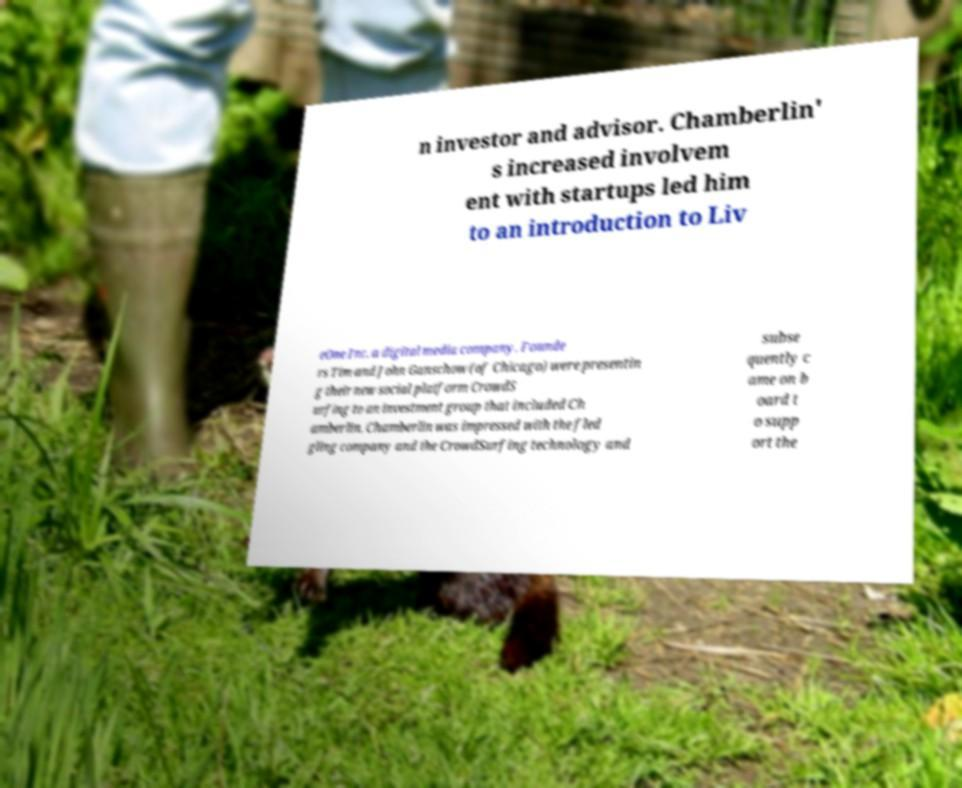For documentation purposes, I need the text within this image transcribed. Could you provide that? n investor and advisor. Chamberlin' s increased involvem ent with startups led him to an introduction to Liv eOne Inc. a digital media company. Founde rs Tim and John Ganschow (of Chicago) were presentin g their new social platform CrowdS urfing to an investment group that included Ch amberlin. Chamberlin was impressed with the fled gling company and the CrowdSurfing technology and subse quently c ame on b oard t o supp ort the 